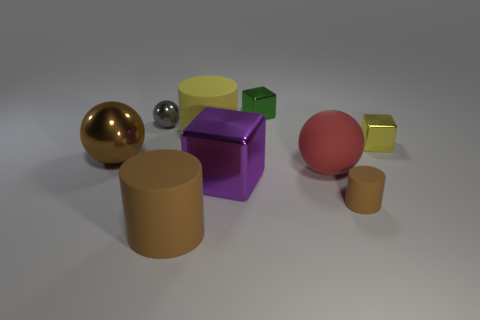There is a large ball that is the same material as the purple object; what color is it?
Offer a very short reply. Brown. Are there the same number of rubber things that are left of the green thing and big purple metallic things?
Make the answer very short. No. There is a rubber thing behind the brown metal object; is its size the same as the small yellow cube?
Your response must be concise. No. The cube that is the same size as the brown sphere is what color?
Offer a terse response. Purple. There is a large metal block that is left of the cylinder that is on the right side of the large yellow cylinder; are there any purple metallic blocks behind it?
Your response must be concise. No. What is the big cylinder in front of the big brown ball made of?
Provide a succinct answer. Rubber. Is the shape of the large brown metallic thing the same as the tiny object left of the large block?
Make the answer very short. Yes. Are there the same number of big cylinders in front of the big matte ball and large yellow objects that are in front of the small gray sphere?
Provide a short and direct response. Yes. How many other things are there of the same material as the big red thing?
Offer a very short reply. 3. What number of metallic objects are small spheres or small gray cylinders?
Your answer should be very brief. 1. 